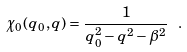<formula> <loc_0><loc_0><loc_500><loc_500>\chi _ { 0 } ( q _ { 0 } , q ) = \frac { 1 } { q _ { 0 } ^ { 2 } - q ^ { 2 } - { \beta } ^ { 2 } } \ .</formula> 